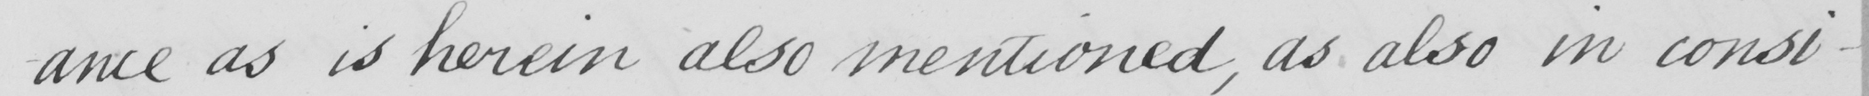Can you read and transcribe this handwriting? -ance as is herein also mentioned , as also in consi- 